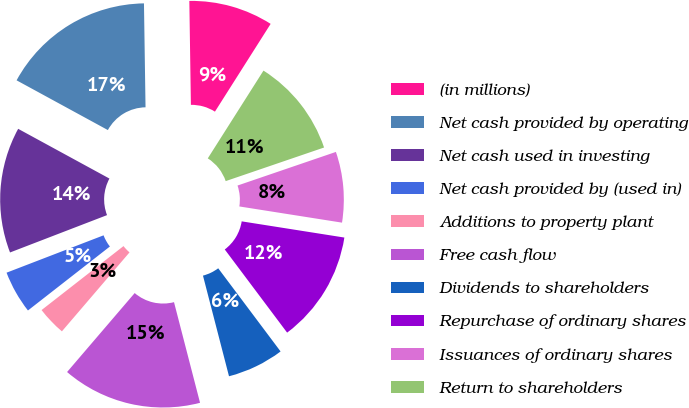<chart> <loc_0><loc_0><loc_500><loc_500><pie_chart><fcel>(in millions)<fcel>Net cash provided by operating<fcel>Net cash used in investing<fcel>Net cash provided by (used in)<fcel>Additions to property plant<fcel>Free cash flow<fcel>Dividends to shareholders<fcel>Repurchase of ordinary shares<fcel>Issuances of ordinary shares<fcel>Return to shareholders<nl><fcel>9.24%<fcel>16.82%<fcel>13.79%<fcel>4.7%<fcel>3.18%<fcel>15.3%<fcel>6.21%<fcel>12.27%<fcel>7.73%<fcel>10.76%<nl></chart> 